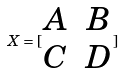Convert formula to latex. <formula><loc_0><loc_0><loc_500><loc_500>X = [ \begin{matrix} A & B \\ C & D \end{matrix} ]</formula> 